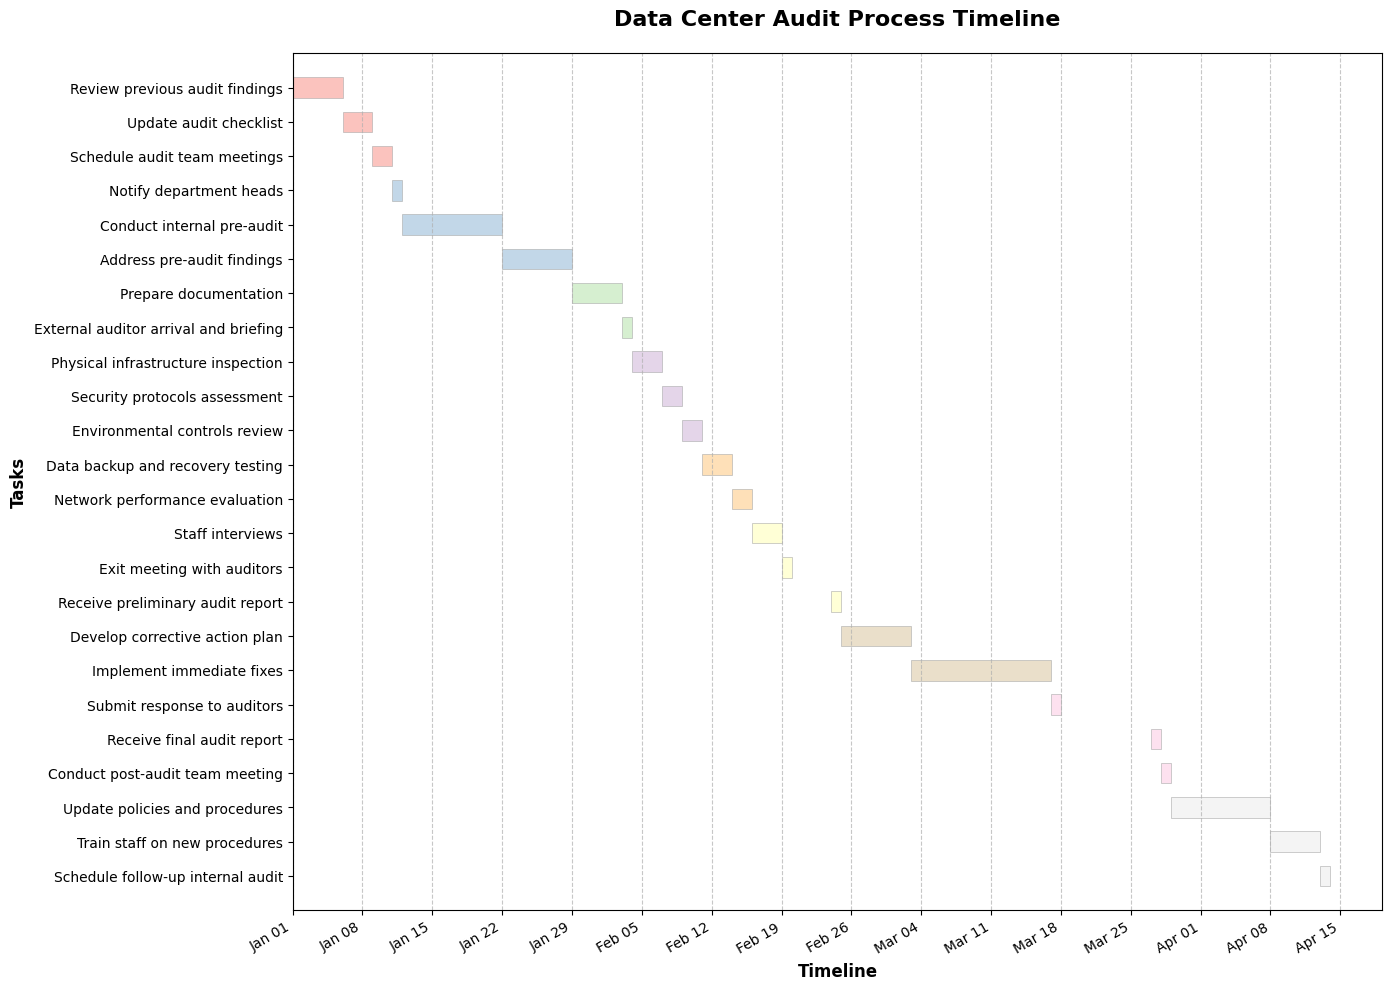How long does the "Conduct internal pre-audit" task take? Identify the duration on the Gantt Chart by locating the task and reading its bar length or tooltip.
Answer: 10 days When does the "External auditor arrival and briefing" start? Locate the "External auditor arrival and briefing" task on the Gantt Chart and read the start date.
Answer: 2024-02-03 What is the end date for "Implement immediate fixes"? Find the "Implement immediate fixes" task, read its start date and duration, then calculate the end date from the start date and duration.
Answer: 2024-03-16 Which task has the longest duration? Compare the lengths of the bars representing the duration of each task to find the longest one.
Answer: Implement immediate fixes How many tasks are scheduled to start in February 2024? Scan the Gantt Chart for tasks starting between February 1, 2024, and February 28, 2024, and count them.
Answer: 8 tasks What is the title of the Gantt Chart? Read the title displayed at the top of the Gantt Chart.
Answer: Data Center Audit Process Timeline Which task comes immediately after "Address pre-audit findings"? Identify the sequence of tasks by checking the start dates and find the next task after "Address pre-audit findings."
Answer: Prepare documentation What is the duration of the "Train staff on new procedures" task? Locate the "Train staff on new procedures" task and check the duration mentioned for this task.
Answer: 5 days Does "Update policies and procedures" start before or after the final audit report? Compare the start dates of "Update policies and procedures" and the date of the "Receive final audit report".
Answer: After How much overlap is there between "Network performance evaluation" and "Staff interviews"? Identify the start and end dates of these tasks; see where they overlap.
Answer: 1 day 